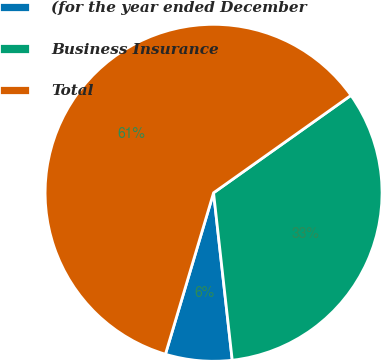<chart> <loc_0><loc_0><loc_500><loc_500><pie_chart><fcel>(for the year ended December<fcel>Business Insurance<fcel>Total<nl><fcel>6.38%<fcel>33.05%<fcel>60.57%<nl></chart> 